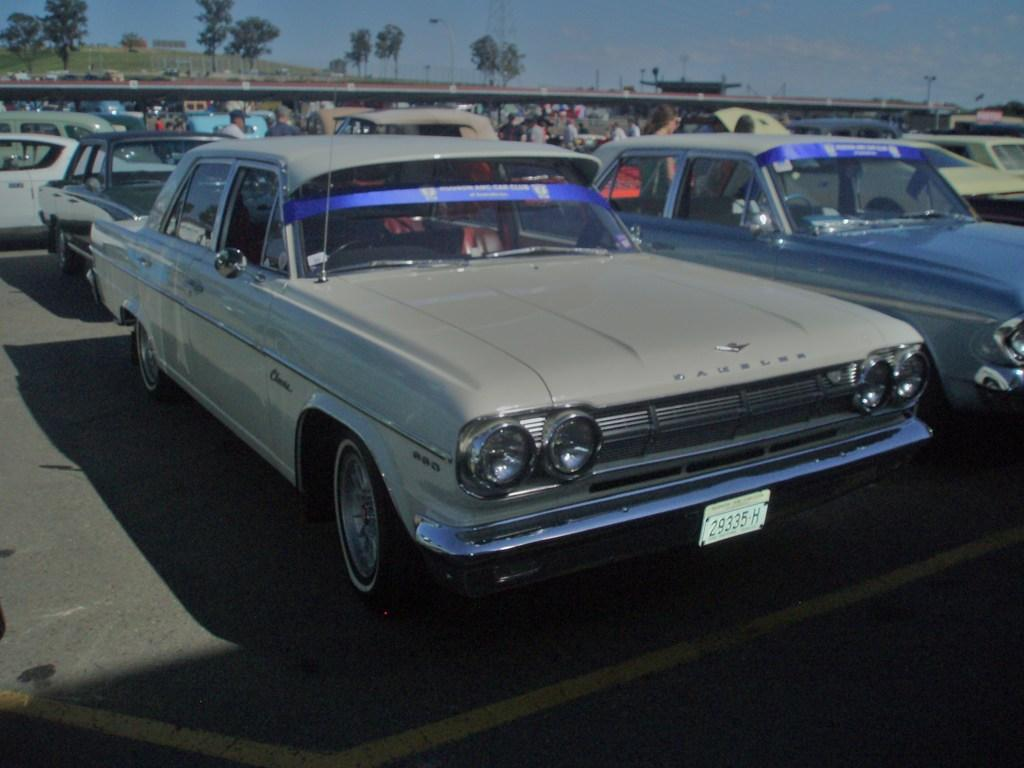<image>
Share a concise interpretation of the image provided. A vintage car in grey with a tag that says 29335 H. 